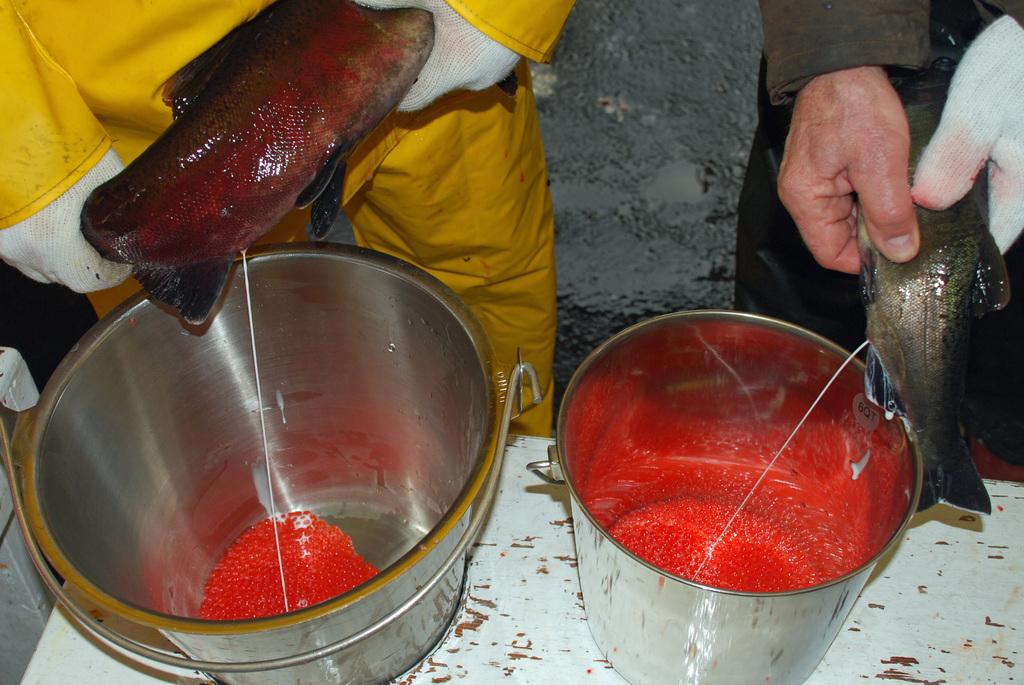What objects are on the table in the image? There are two buckets on the table in the image. How many people are present in the image? There are two persons in the image. What are the persons holding in their hands? The persons are holding fish in their hands. What can be seen in the background of the image? The sky is visible in the background of the image. What type of debt is being discussed by the persons in the image? There is no indication of a debt being discussed in the image; the persons are holding fish. 